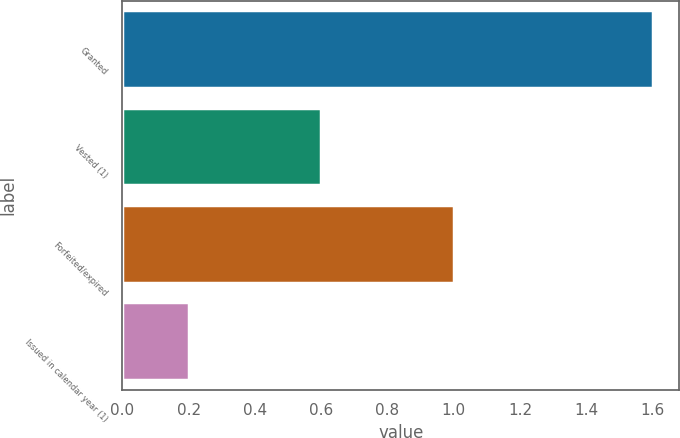Convert chart. <chart><loc_0><loc_0><loc_500><loc_500><bar_chart><fcel>Granted<fcel>Vested (1)<fcel>Forfeited/expired<fcel>Issued in calendar year (1)<nl><fcel>1.6<fcel>0.6<fcel>1<fcel>0.2<nl></chart> 